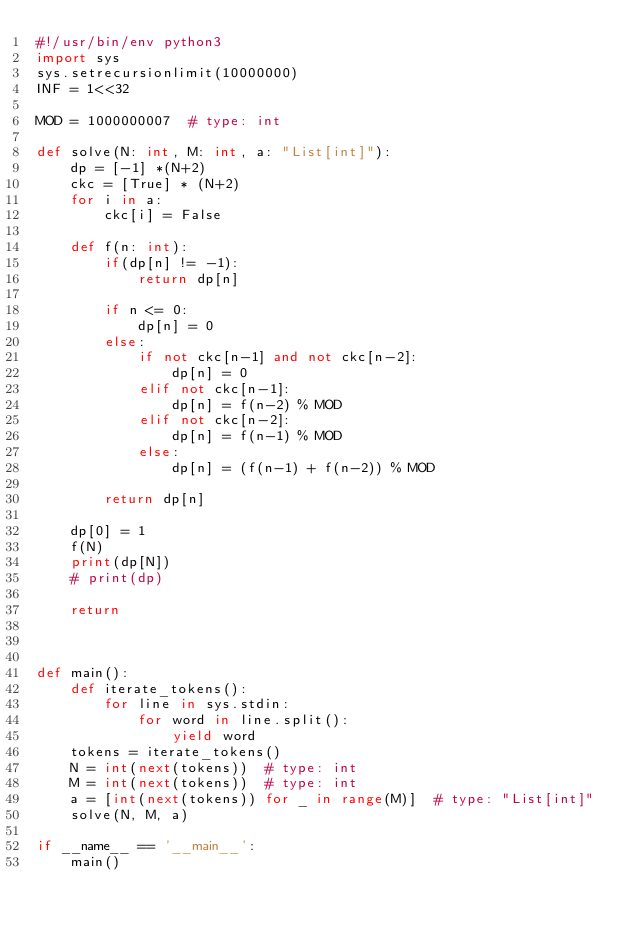Convert code to text. <code><loc_0><loc_0><loc_500><loc_500><_Python_>#!/usr/bin/env python3
import sys
sys.setrecursionlimit(10000000)
INF = 1<<32

MOD = 1000000007  # type: int

def solve(N: int, M: int, a: "List[int]"):
    dp = [-1] *(N+2)
    ckc = [True] * (N+2)
    for i in a:
        ckc[i] = False

    def f(n: int):
        if(dp[n] != -1):
            return dp[n]

        if n <= 0:
            dp[n] = 0
        else:
            if not ckc[n-1] and not ckc[n-2]:
                dp[n] = 0
            elif not ckc[n-1]:
                dp[n] = f(n-2) % MOD
            elif not ckc[n-2]:
                dp[n] = f(n-1) % MOD
            else:
                dp[n] = (f(n-1) + f(n-2)) % MOD
            
        return dp[n]

    dp[0] = 1
    f(N)
    print(dp[N])
    # print(dp)

    return



def main():
    def iterate_tokens():
        for line in sys.stdin:
            for word in line.split():
                yield word
    tokens = iterate_tokens()
    N = int(next(tokens))  # type: int
    M = int(next(tokens))  # type: int
    a = [int(next(tokens)) for _ in range(M)]  # type: "List[int]"
    solve(N, M, a)

if __name__ == '__main__':
    main()
</code> 